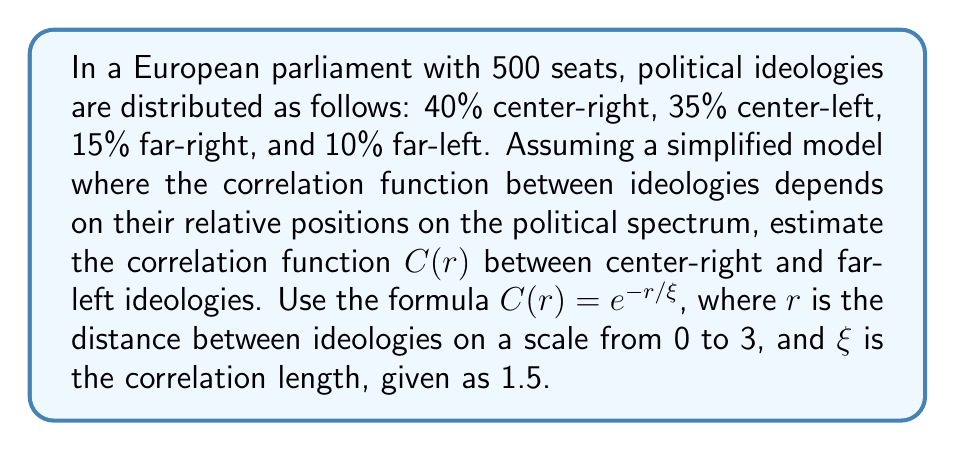Can you solve this math problem? To solve this problem, we'll follow these steps:

1. Determine the distance $r$ between center-right and far-left ideologies:
   - Center-right is at position 1 on the scale (0 to 3)
   - Far-left is at position 3 on the scale
   - $r = 3 - 1 = 2$

2. Use the given correlation function formula:
   $C(r) = e^{-r/\xi}$

3. Substitute the values:
   - $r = 2$
   - $\xi = 1.5$

4. Calculate:
   $C(2) = e^{-2/1.5}$

5. Simplify:
   $C(2) = e^{-4/3} \approx 0.2466$

This result indicates a weak positive correlation between center-right and far-left ideologies, which aligns with the expected political dynamics in a diverse European parliament.
Answer: $C(2) = e^{-4/3} \approx 0.2466$ 